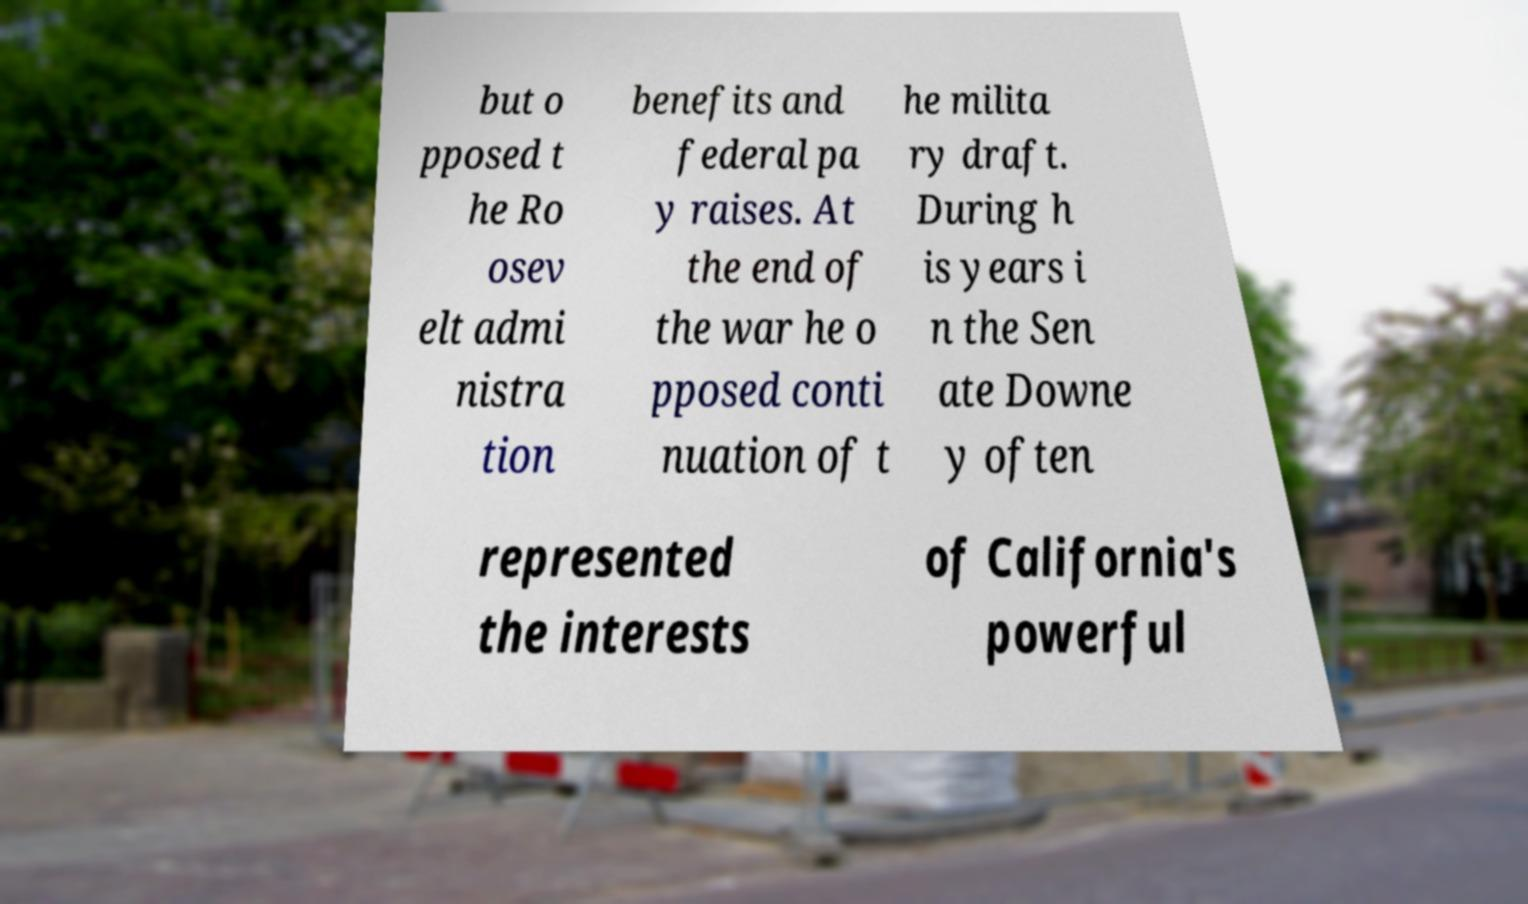Can you accurately transcribe the text from the provided image for me? but o pposed t he Ro osev elt admi nistra tion benefits and federal pa y raises. At the end of the war he o pposed conti nuation of t he milita ry draft. During h is years i n the Sen ate Downe y often represented the interests of California's powerful 